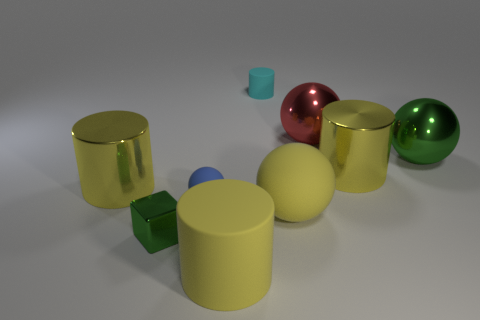How many large yellow shiny things have the same shape as the big green object?
Offer a very short reply. 0. There is a green metal thing that is to the left of the cyan matte thing; how many green metallic spheres are in front of it?
Provide a short and direct response. 0. How many shiny things are either large yellow cylinders or yellow objects?
Offer a very short reply. 2. Is there a small blue ball made of the same material as the large green sphere?
Provide a succinct answer. No. How many things are either yellow cylinders on the left side of the large red ball or shiny cylinders left of the blue sphere?
Provide a short and direct response. 2. There is a rubber cylinder that is on the left side of the tiny cylinder; does it have the same color as the big matte sphere?
Keep it short and to the point. Yes. How many other objects are there of the same color as the small shiny cube?
Provide a succinct answer. 1. What is the material of the big green thing?
Ensure brevity in your answer.  Metal. There is a green thing that is in front of the blue rubber object; is its size the same as the yellow matte ball?
Your answer should be very brief. No. What is the size of the yellow thing that is the same shape as the big red shiny object?
Keep it short and to the point. Large. 